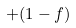Convert formula to latex. <formula><loc_0><loc_0><loc_500><loc_500>+ ( 1 - f )</formula> 